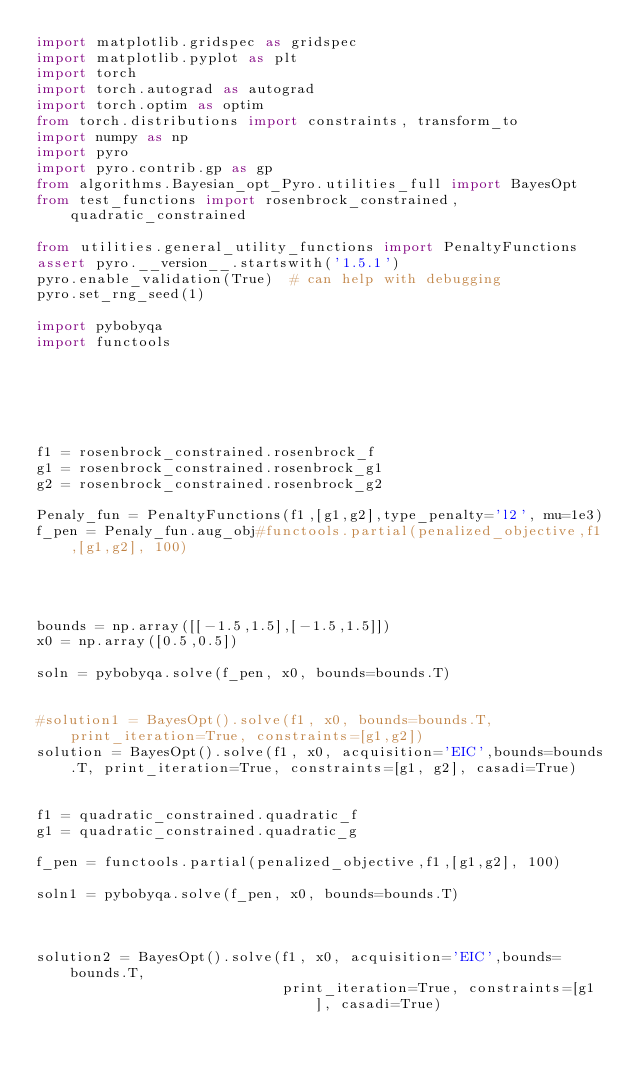Convert code to text. <code><loc_0><loc_0><loc_500><loc_500><_Python_>import matplotlib.gridspec as gridspec
import matplotlib.pyplot as plt
import torch
import torch.autograd as autograd
import torch.optim as optim
from torch.distributions import constraints, transform_to
import numpy as np
import pyro
import pyro.contrib.gp as gp
from algorithms.Bayesian_opt_Pyro.utilities_full import BayesOpt
from test_functions import rosenbrock_constrained, quadratic_constrained

from utilities.general_utility_functions import PenaltyFunctions
assert pyro.__version__.startswith('1.5.1')
pyro.enable_validation(True)  # can help with debugging
pyro.set_rng_seed(1)

import pybobyqa
import functools






f1 = rosenbrock_constrained.rosenbrock_f
g1 = rosenbrock_constrained.rosenbrock_g1
g2 = rosenbrock_constrained.rosenbrock_g2

Penaly_fun = PenaltyFunctions(f1,[g1,g2],type_penalty='l2', mu=1e3)
f_pen = Penaly_fun.aug_obj#functools.partial(penalized_objective,f1,[g1,g2], 100)




bounds = np.array([[-1.5,1.5],[-1.5,1.5]])
x0 = np.array([0.5,0.5])

soln = pybobyqa.solve(f_pen, x0, bounds=bounds.T)


#solution1 = BayesOpt().solve(f1, x0, bounds=bounds.T, print_iteration=True, constraints=[g1,g2])
solution = BayesOpt().solve(f1, x0, acquisition='EIC',bounds=bounds.T, print_iteration=True, constraints=[g1, g2], casadi=True)


f1 = quadratic_constrained.quadratic_f
g1 = quadratic_constrained.quadratic_g

f_pen = functools.partial(penalized_objective,f1,[g1,g2], 100)

soln1 = pybobyqa.solve(f_pen, x0, bounds=bounds.T)



solution2 = BayesOpt().solve(f1, x0, acquisition='EIC',bounds=bounds.T,
                             print_iteration=True, constraints=[g1], casadi=True)
</code> 